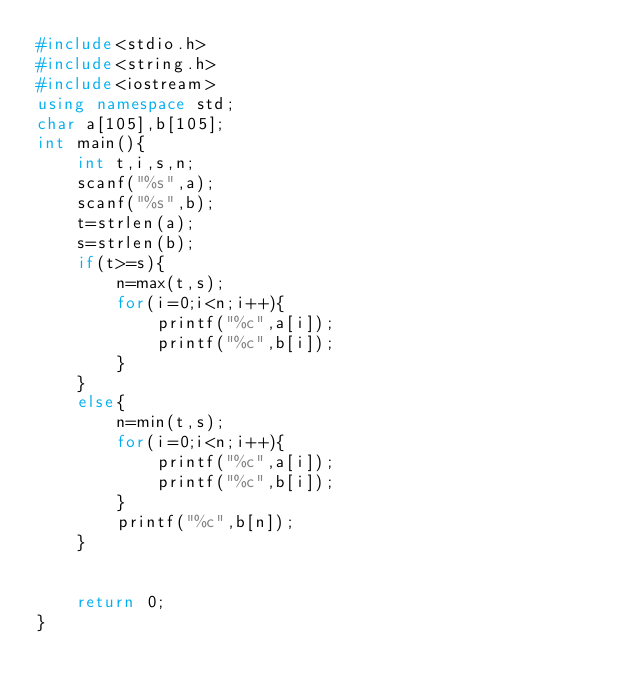Convert code to text. <code><loc_0><loc_0><loc_500><loc_500><_C++_>#include<stdio.h>
#include<string.h>
#include<iostream>
using namespace std;
char a[105],b[105];
int main(){
    int t,i,s,n;
    scanf("%s",a);
    scanf("%s",b);
    t=strlen(a);
    s=strlen(b);
    if(t>=s){
        n=max(t,s);
        for(i=0;i<n;i++){
            printf("%c",a[i]);
            printf("%c",b[i]);
        }
    }
    else{
        n=min(t,s);
        for(i=0;i<n;i++){
            printf("%c",a[i]);
            printf("%c",b[i]);
        }
        printf("%c",b[n]);
    }


    return 0;
}
</code> 